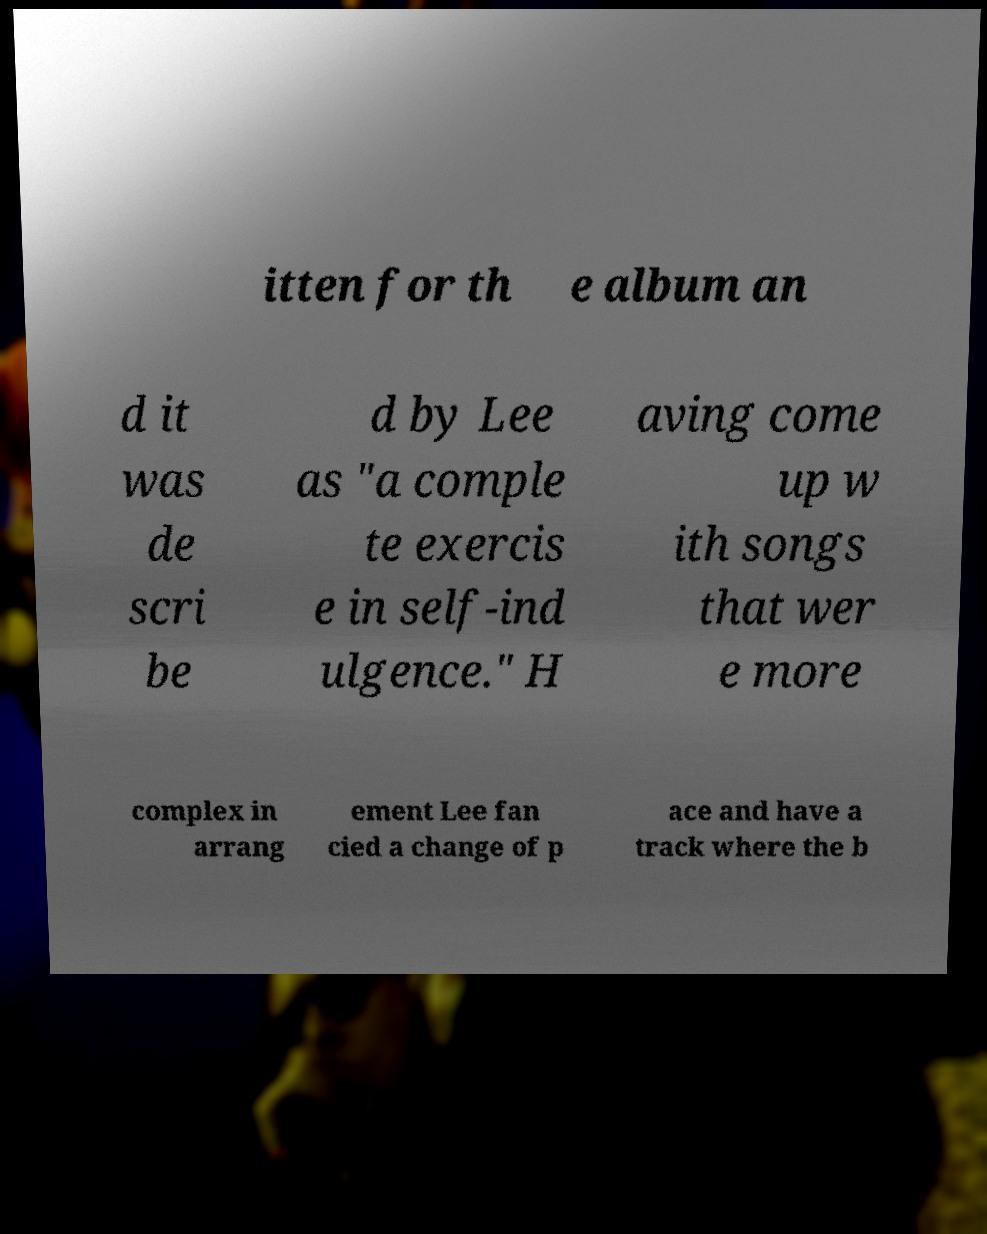Could you assist in decoding the text presented in this image and type it out clearly? itten for th e album an d it was de scri be d by Lee as "a comple te exercis e in self-ind ulgence." H aving come up w ith songs that wer e more complex in arrang ement Lee fan cied a change of p ace and have a track where the b 